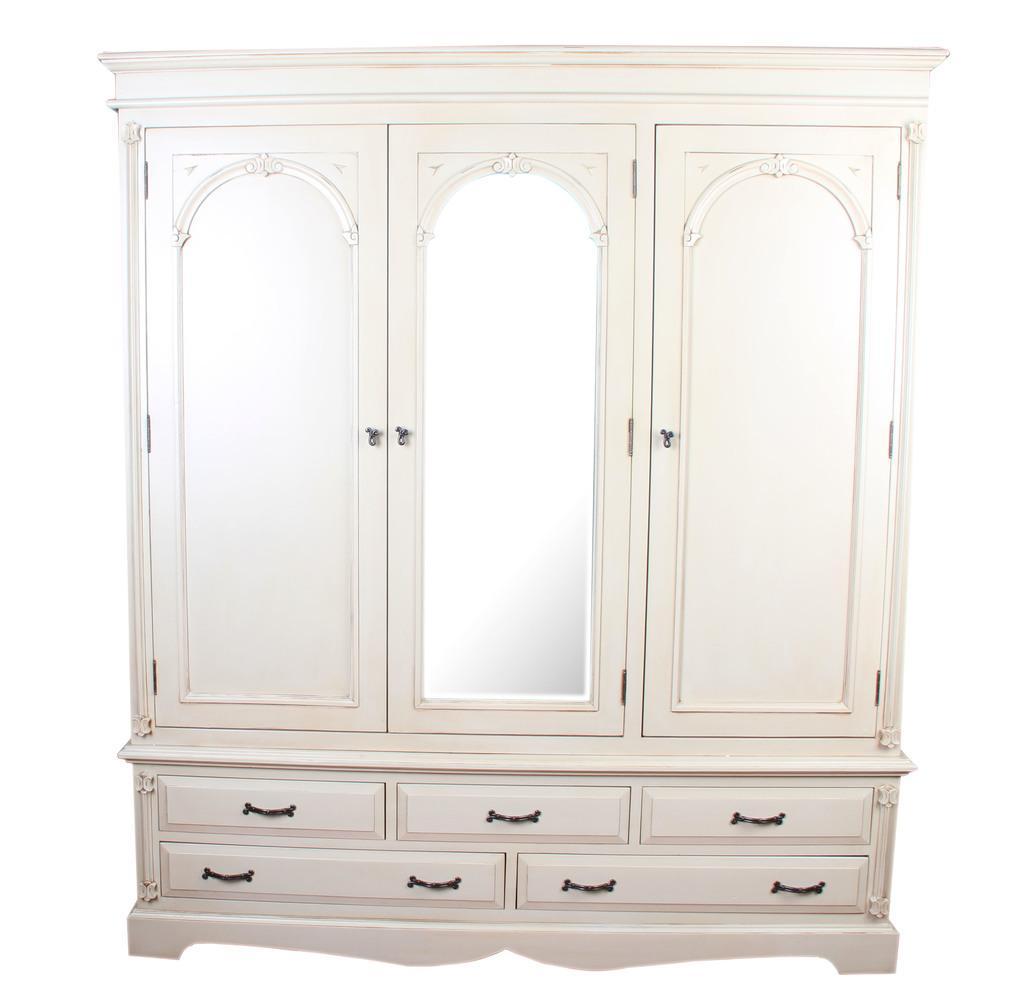Describe this image in one or two sentences. In this image we can see a wardrobe. 